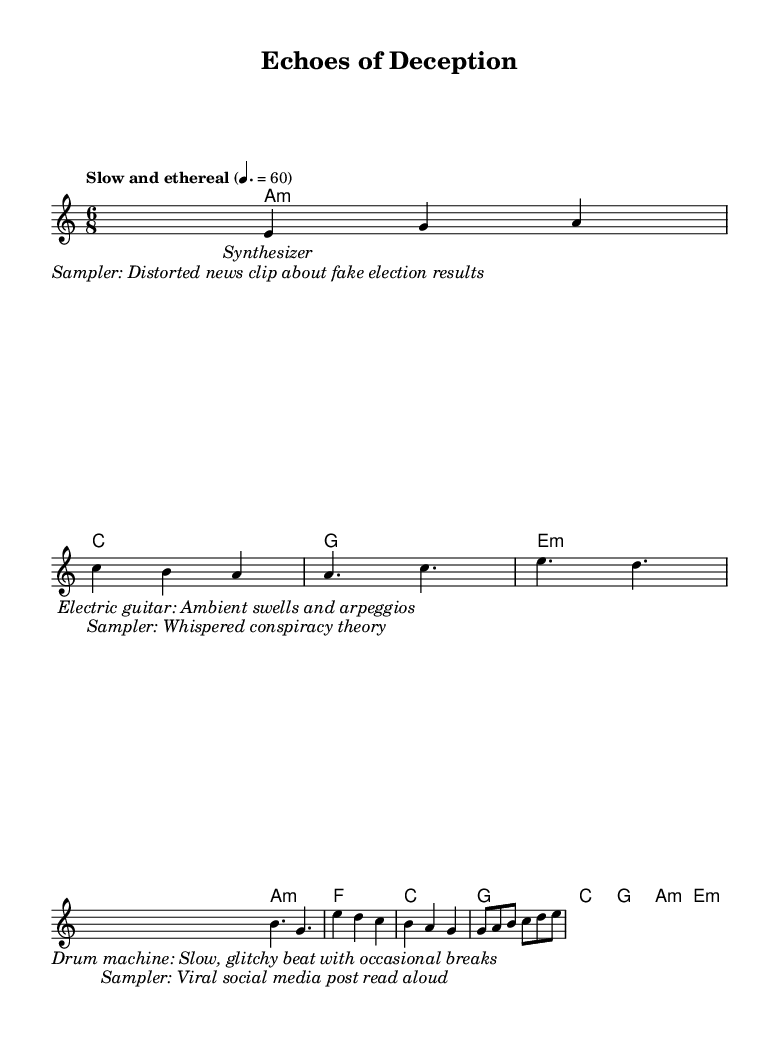What is the key signature of this music? The key signature is A minor, which has no sharps or flats just like C major, but recognizes A as its tonic.
Answer: A minor What is the time signature of this music? The time signature is 6/8, which indicates that there are six eighth notes per measure. This can be seen clearly at the beginning of the sheet music.
Answer: 6/8 What is the tempo marking for this piece? The tempo marking is "Slow and ethereal," and the tempo is set at a quarter note equals 60 beats per minute, prominent at the top of the sheet music.
Answer: Slow and ethereal How many distinct lyrical components are there in the piece? There are two distinct lyrical components, one focusing on instrumental descriptions and the other incorporating snippets of misinformation. Each has its own separate set of lyrics.
Answer: 2 What instruments are specified for the music? The piece specifies synthesizer, electric guitar, and a drum machine, based on the lyrics and markings indicating their roles in the composition.
Answer: Synthesizer, electric guitar, drum machine What kind of audio samples are incorporated within the music? The music incorporates audio samples that include a distorted news clip about fake election results and whispered conspiracy theories, evident in the second lyrical segment of the sheet music.
Answer: Distorted news clip, whispered conspiracy theory What is the overall theme of the lyrics in this music? The overall theme revolves around misinformation, with lyrics explicitly describing snippets related to fake news and viral social media posts, illustrating how these elements influence perceptions.
Answer: Misinformation 